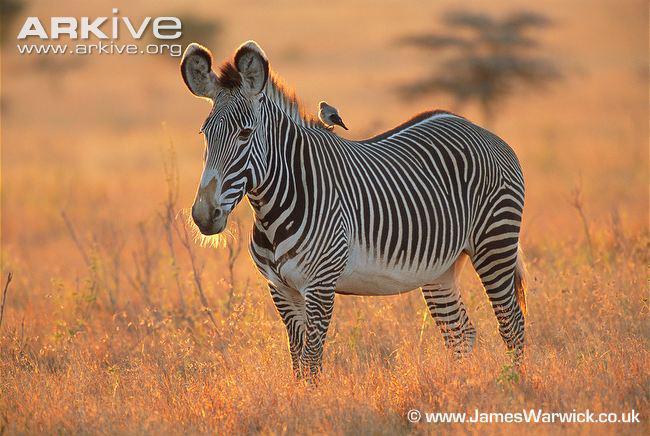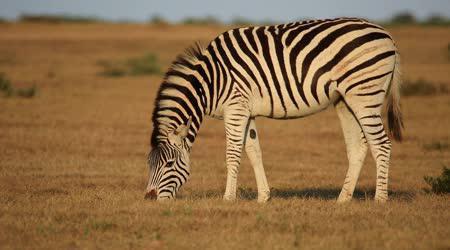The first image is the image on the left, the second image is the image on the right. Assess this claim about the two images: "There are animals fighting.". Correct or not? Answer yes or no. No. The first image is the image on the left, the second image is the image on the right. Given the left and right images, does the statement "A lion is pouncing on a zebra in one of the images." hold true? Answer yes or no. No. 